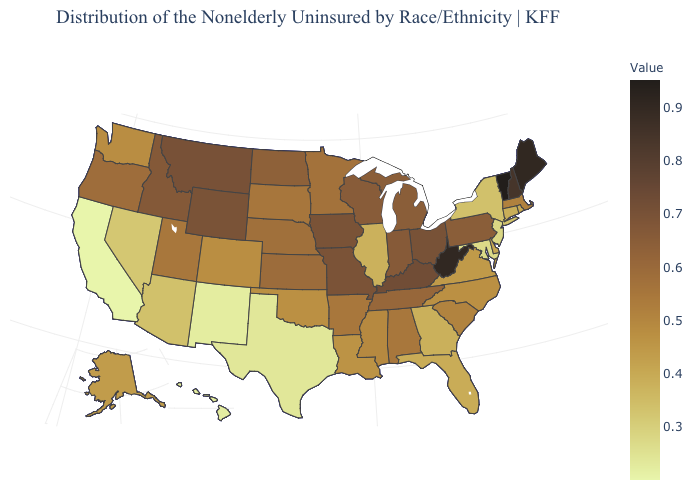Which states have the highest value in the USA?
Keep it brief. Vermont. Does Vermont have the highest value in the USA?
Concise answer only. Yes. Does South Dakota have the lowest value in the USA?
Concise answer only. No. Does Ohio have the highest value in the MidWest?
Write a very short answer. Yes. Does Vermont have the highest value in the USA?
Quick response, please. Yes. 